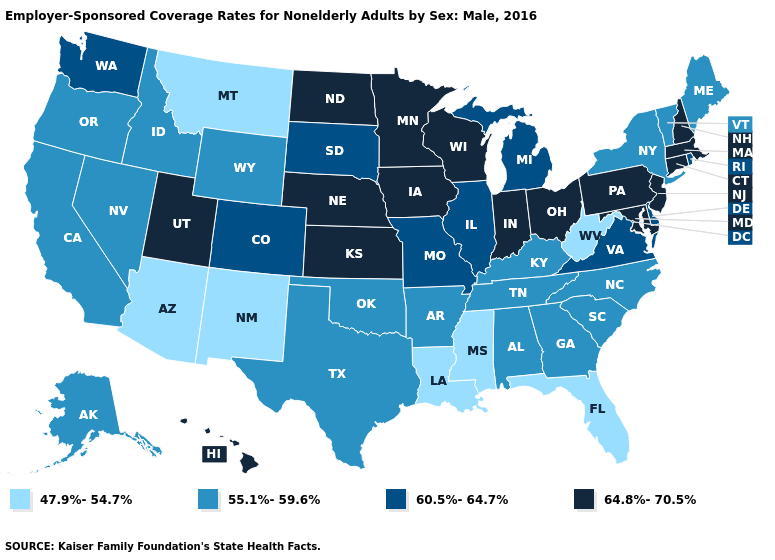What is the value of Maryland?
Short answer required. 64.8%-70.5%. Name the states that have a value in the range 47.9%-54.7%?
Short answer required. Arizona, Florida, Louisiana, Mississippi, Montana, New Mexico, West Virginia. Name the states that have a value in the range 55.1%-59.6%?
Concise answer only. Alabama, Alaska, Arkansas, California, Georgia, Idaho, Kentucky, Maine, Nevada, New York, North Carolina, Oklahoma, Oregon, South Carolina, Tennessee, Texas, Vermont, Wyoming. Name the states that have a value in the range 47.9%-54.7%?
Be succinct. Arizona, Florida, Louisiana, Mississippi, Montana, New Mexico, West Virginia. Does Colorado have the same value as Washington?
Quick response, please. Yes. Does New Mexico have the highest value in the USA?
Concise answer only. No. Which states have the highest value in the USA?
Write a very short answer. Connecticut, Hawaii, Indiana, Iowa, Kansas, Maryland, Massachusetts, Minnesota, Nebraska, New Hampshire, New Jersey, North Dakota, Ohio, Pennsylvania, Utah, Wisconsin. What is the value of New Hampshire?
Answer briefly. 64.8%-70.5%. Name the states that have a value in the range 64.8%-70.5%?
Short answer required. Connecticut, Hawaii, Indiana, Iowa, Kansas, Maryland, Massachusetts, Minnesota, Nebraska, New Hampshire, New Jersey, North Dakota, Ohio, Pennsylvania, Utah, Wisconsin. Name the states that have a value in the range 47.9%-54.7%?
Give a very brief answer. Arizona, Florida, Louisiana, Mississippi, Montana, New Mexico, West Virginia. Which states have the highest value in the USA?
Give a very brief answer. Connecticut, Hawaii, Indiana, Iowa, Kansas, Maryland, Massachusetts, Minnesota, Nebraska, New Hampshire, New Jersey, North Dakota, Ohio, Pennsylvania, Utah, Wisconsin. Among the states that border Nebraska , which have the highest value?
Concise answer only. Iowa, Kansas. Which states have the highest value in the USA?
Concise answer only. Connecticut, Hawaii, Indiana, Iowa, Kansas, Maryland, Massachusetts, Minnesota, Nebraska, New Hampshire, New Jersey, North Dakota, Ohio, Pennsylvania, Utah, Wisconsin. Does Arkansas have a lower value than Arizona?
Write a very short answer. No. Does West Virginia have the lowest value in the USA?
Keep it brief. Yes. 